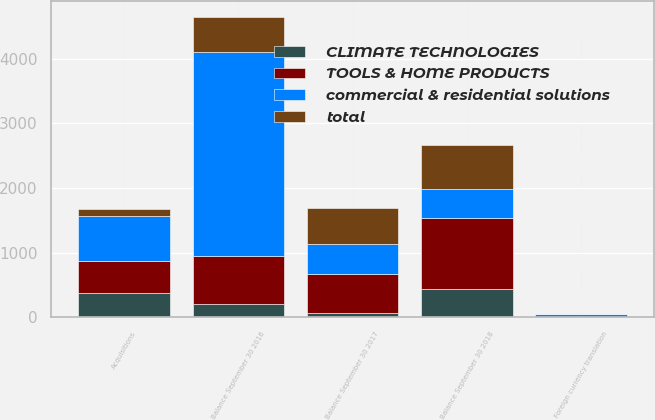Convert chart. <chart><loc_0><loc_0><loc_500><loc_500><stacked_bar_chart><ecel><fcel>Balance September 30 2016<fcel>Balance September 30 2017<fcel>Acquisitions<fcel>Foreign currency translation<fcel>Balance September 30 2018<nl><fcel>commercial & residential solutions<fcel>3160<fcel>461<fcel>696<fcel>45<fcel>461<nl><fcel>total<fcel>553<fcel>555<fcel>118<fcel>3<fcel>670<nl><fcel>CLIMATE TECHNOLOGIES<fcel>196<fcel>57<fcel>374<fcel>1<fcel>430<nl><fcel>TOOLS & HOME PRODUCTS<fcel>749<fcel>612<fcel>492<fcel>4<fcel>1100<nl></chart> 